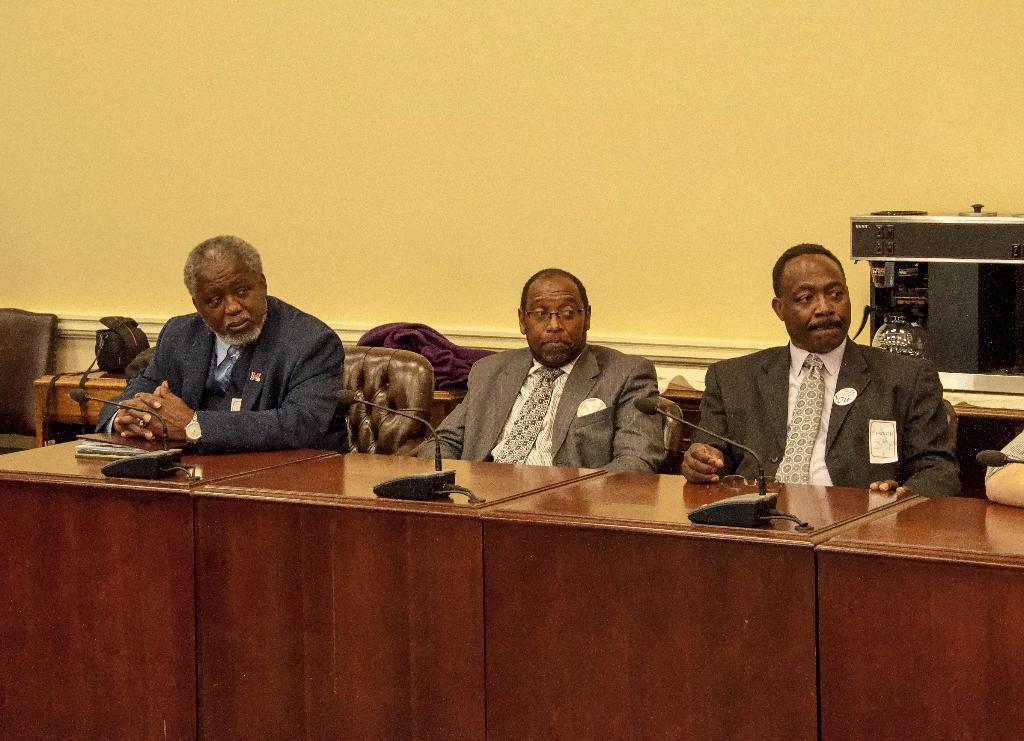Please provide a concise description of this image. These three persons are sitting on the chair. We can see tables and chairs,on the table there are microphones, book. On the background we can see wall. 